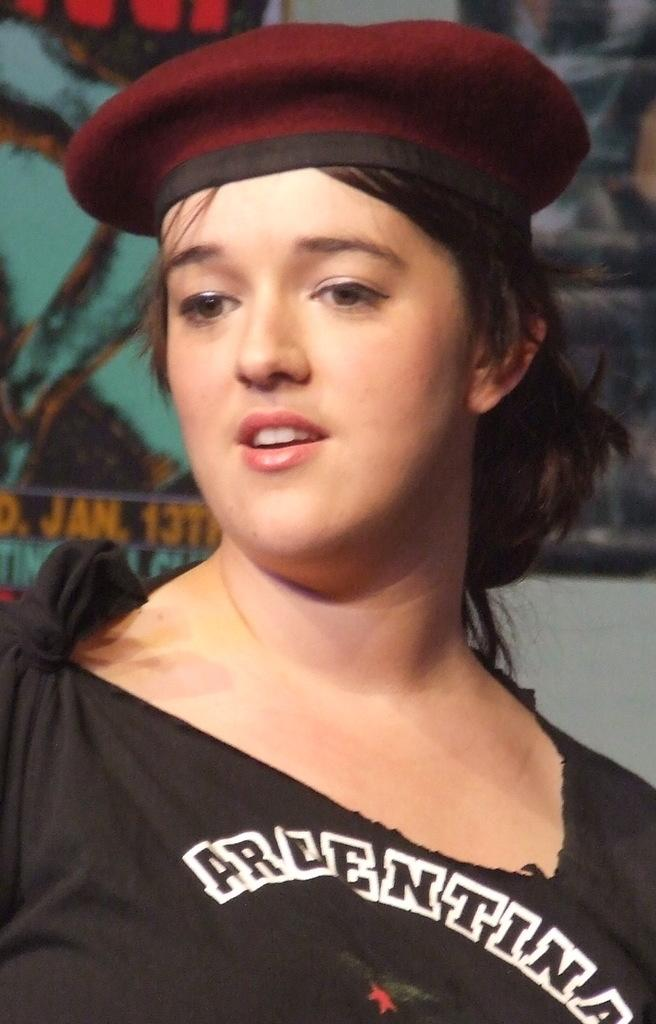Who is present in the image? There is a woman in the image. What is the woman wearing on her head? The woman is wearing a cap. What is the woman's facial expression? The woman is smiling. What can be seen on the wall in the background of the image? There are frames on the wall in the background of the image. What type of book is the woman holding in the image? There is no book present in the image; the woman is not holding anything. 